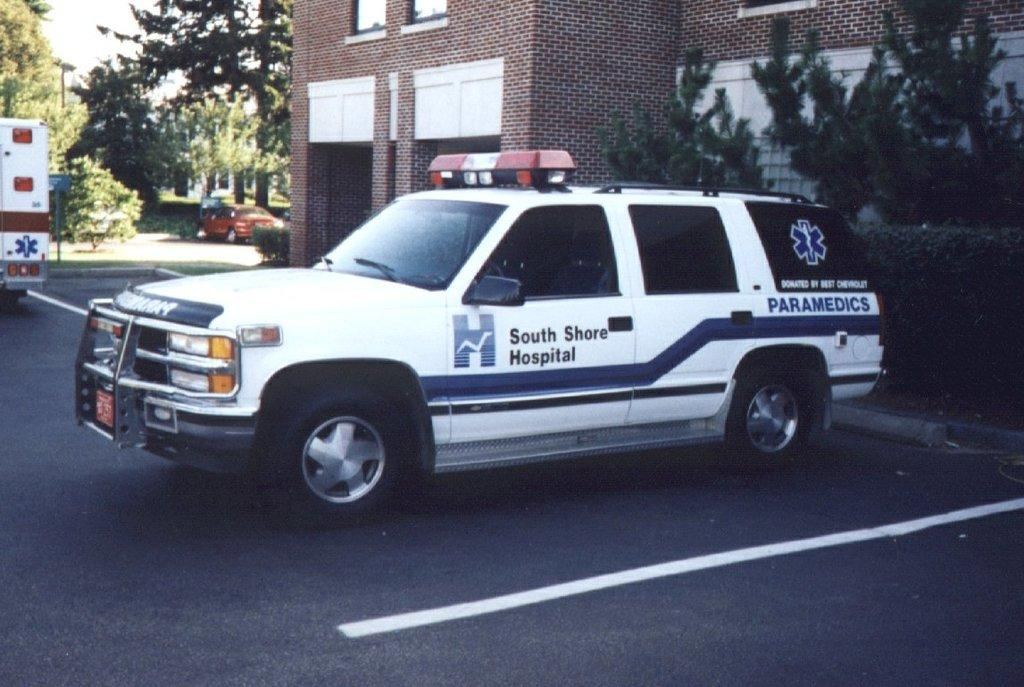What is located in the middle of the image? There are vehicles in the middle of the image. What can be seen in the background of the image? There are trees and a building in the background of the image. What is at the bottom of the image? There is a road at the bottom of the image. Can you see a thumbprint on the face of the building in the image? There is no thumbprint or face present on the building in the image; it is a regular building in the background. 